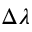Convert formula to latex. <formula><loc_0><loc_0><loc_500><loc_500>\Delta \lambda</formula> 